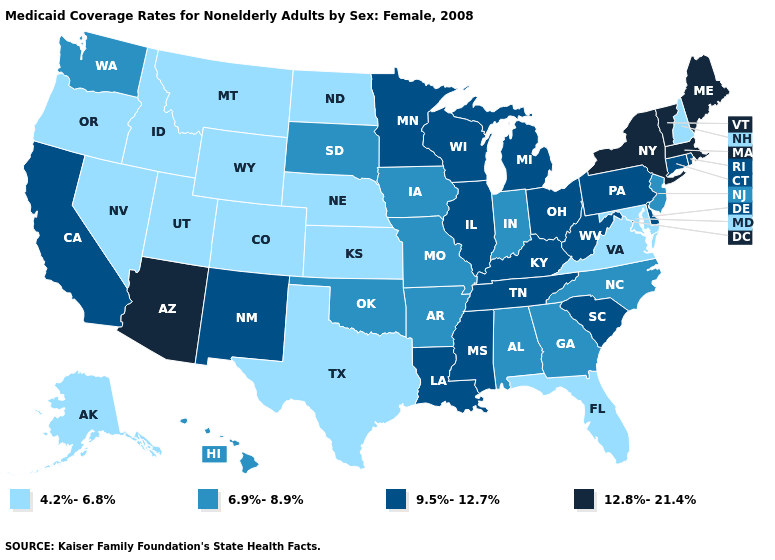Does Maryland have the lowest value in the South?
Write a very short answer. Yes. What is the value of New York?
Quick response, please. 12.8%-21.4%. Name the states that have a value in the range 4.2%-6.8%?
Be succinct. Alaska, Colorado, Florida, Idaho, Kansas, Maryland, Montana, Nebraska, Nevada, New Hampshire, North Dakota, Oregon, Texas, Utah, Virginia, Wyoming. Is the legend a continuous bar?
Give a very brief answer. No. Does the map have missing data?
Concise answer only. No. What is the lowest value in the USA?
Short answer required. 4.2%-6.8%. Name the states that have a value in the range 6.9%-8.9%?
Short answer required. Alabama, Arkansas, Georgia, Hawaii, Indiana, Iowa, Missouri, New Jersey, North Carolina, Oklahoma, South Dakota, Washington. What is the highest value in states that border Pennsylvania?
Quick response, please. 12.8%-21.4%. Name the states that have a value in the range 4.2%-6.8%?
Quick response, please. Alaska, Colorado, Florida, Idaho, Kansas, Maryland, Montana, Nebraska, Nevada, New Hampshire, North Dakota, Oregon, Texas, Utah, Virginia, Wyoming. What is the value of Nebraska?
Keep it brief. 4.2%-6.8%. What is the value of Georgia?
Be succinct. 6.9%-8.9%. What is the value of Utah?
Quick response, please. 4.2%-6.8%. Which states have the lowest value in the USA?
Quick response, please. Alaska, Colorado, Florida, Idaho, Kansas, Maryland, Montana, Nebraska, Nevada, New Hampshire, North Dakota, Oregon, Texas, Utah, Virginia, Wyoming. What is the value of Mississippi?
Keep it brief. 9.5%-12.7%. Name the states that have a value in the range 12.8%-21.4%?
Write a very short answer. Arizona, Maine, Massachusetts, New York, Vermont. 